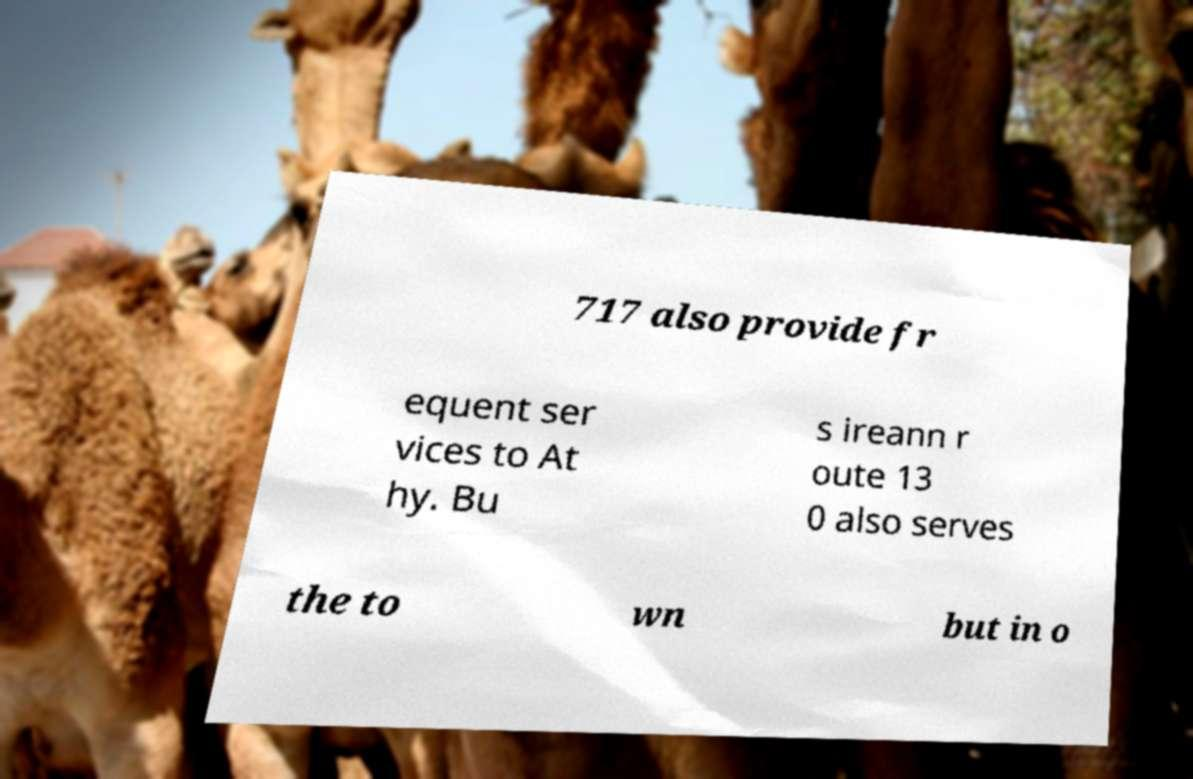Can you accurately transcribe the text from the provided image for me? 717 also provide fr equent ser vices to At hy. Bu s ireann r oute 13 0 also serves the to wn but in o 